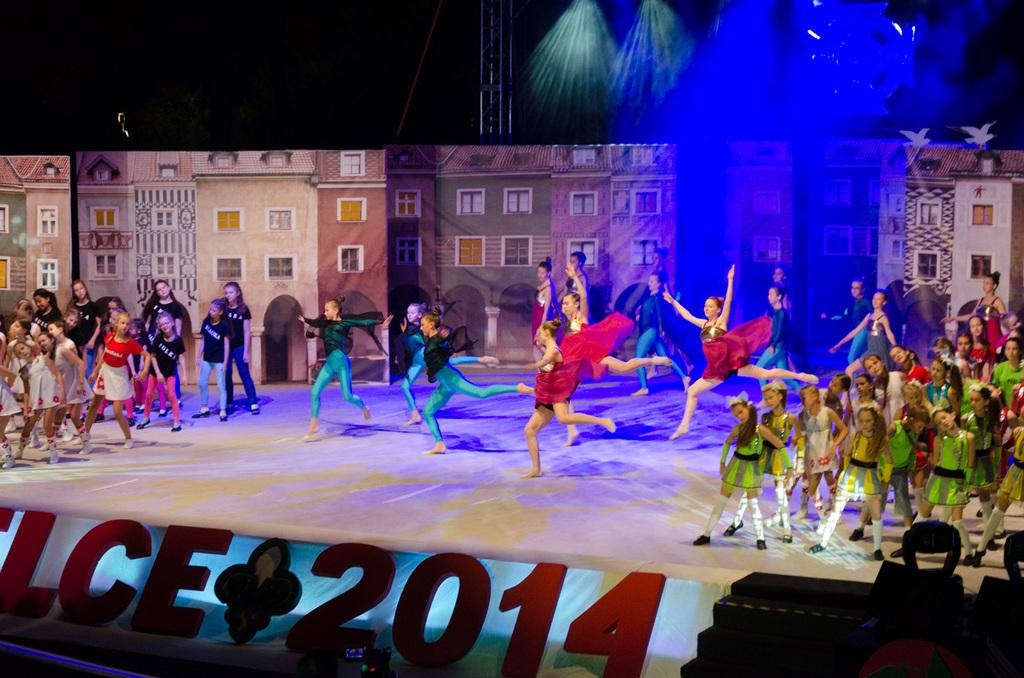What type of structure can be seen in the image? There is a stage in the image. What is located near the stage? There are boards and steps visible in the image. Who or what is present on or around the stage? There are people in the image. What can be seen illuminating the stage? Focusing lights are visible in the image. What architectural feature is present in the image? There is a beam in the image. What else can be seen in the background of the image? There are buildings in the image. Can you describe any other objects in the image? There are objects in the image. What type of stew is being served on the stage in the image? There is no stew present on the stage in the image. What color are the straws used by the people in the image? There are no straws visible in the image. 